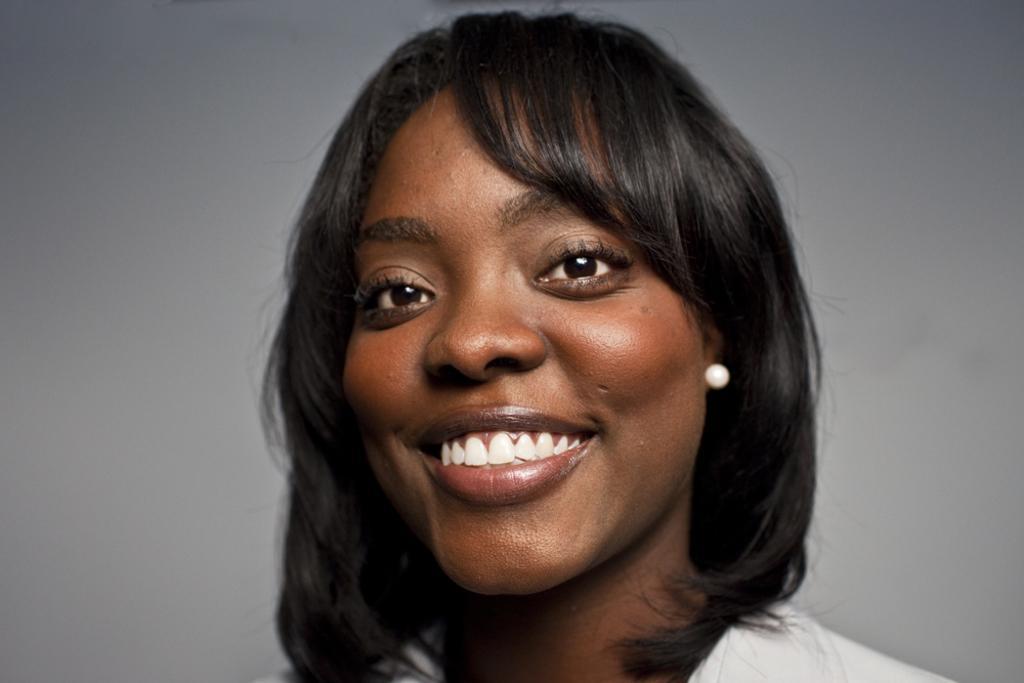Could you give a brief overview of what you see in this image? In this image we can see a lady smiling. In the background there is a wall. 